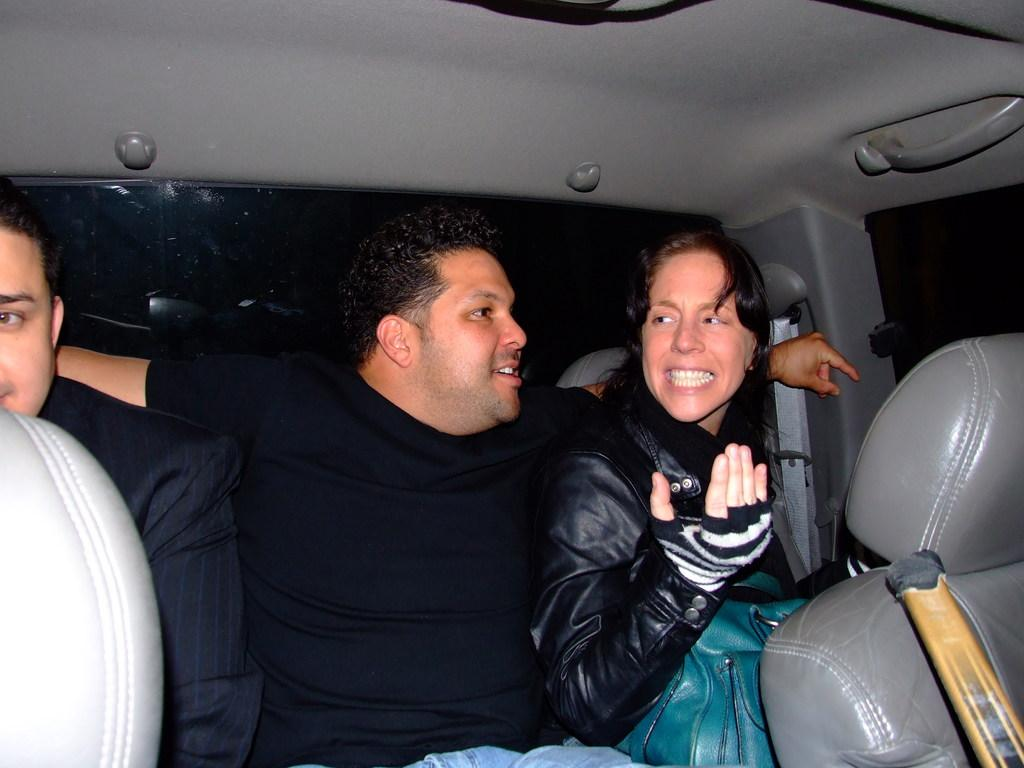How many people are in the image? There are two men and a woman in the image. What are the men wearing? One man is wearing a suit, and the other man is wearing a T-shirt. What is the woman wearing? The woman is wearing a black coat. What accessory does the woman have with her? The woman has a green bag with her. What type of knee surgery did the man in the suit undergo? There is no indication in the image that any of the individuals have undergone knee surgery, and therefore no such information can be provided. 